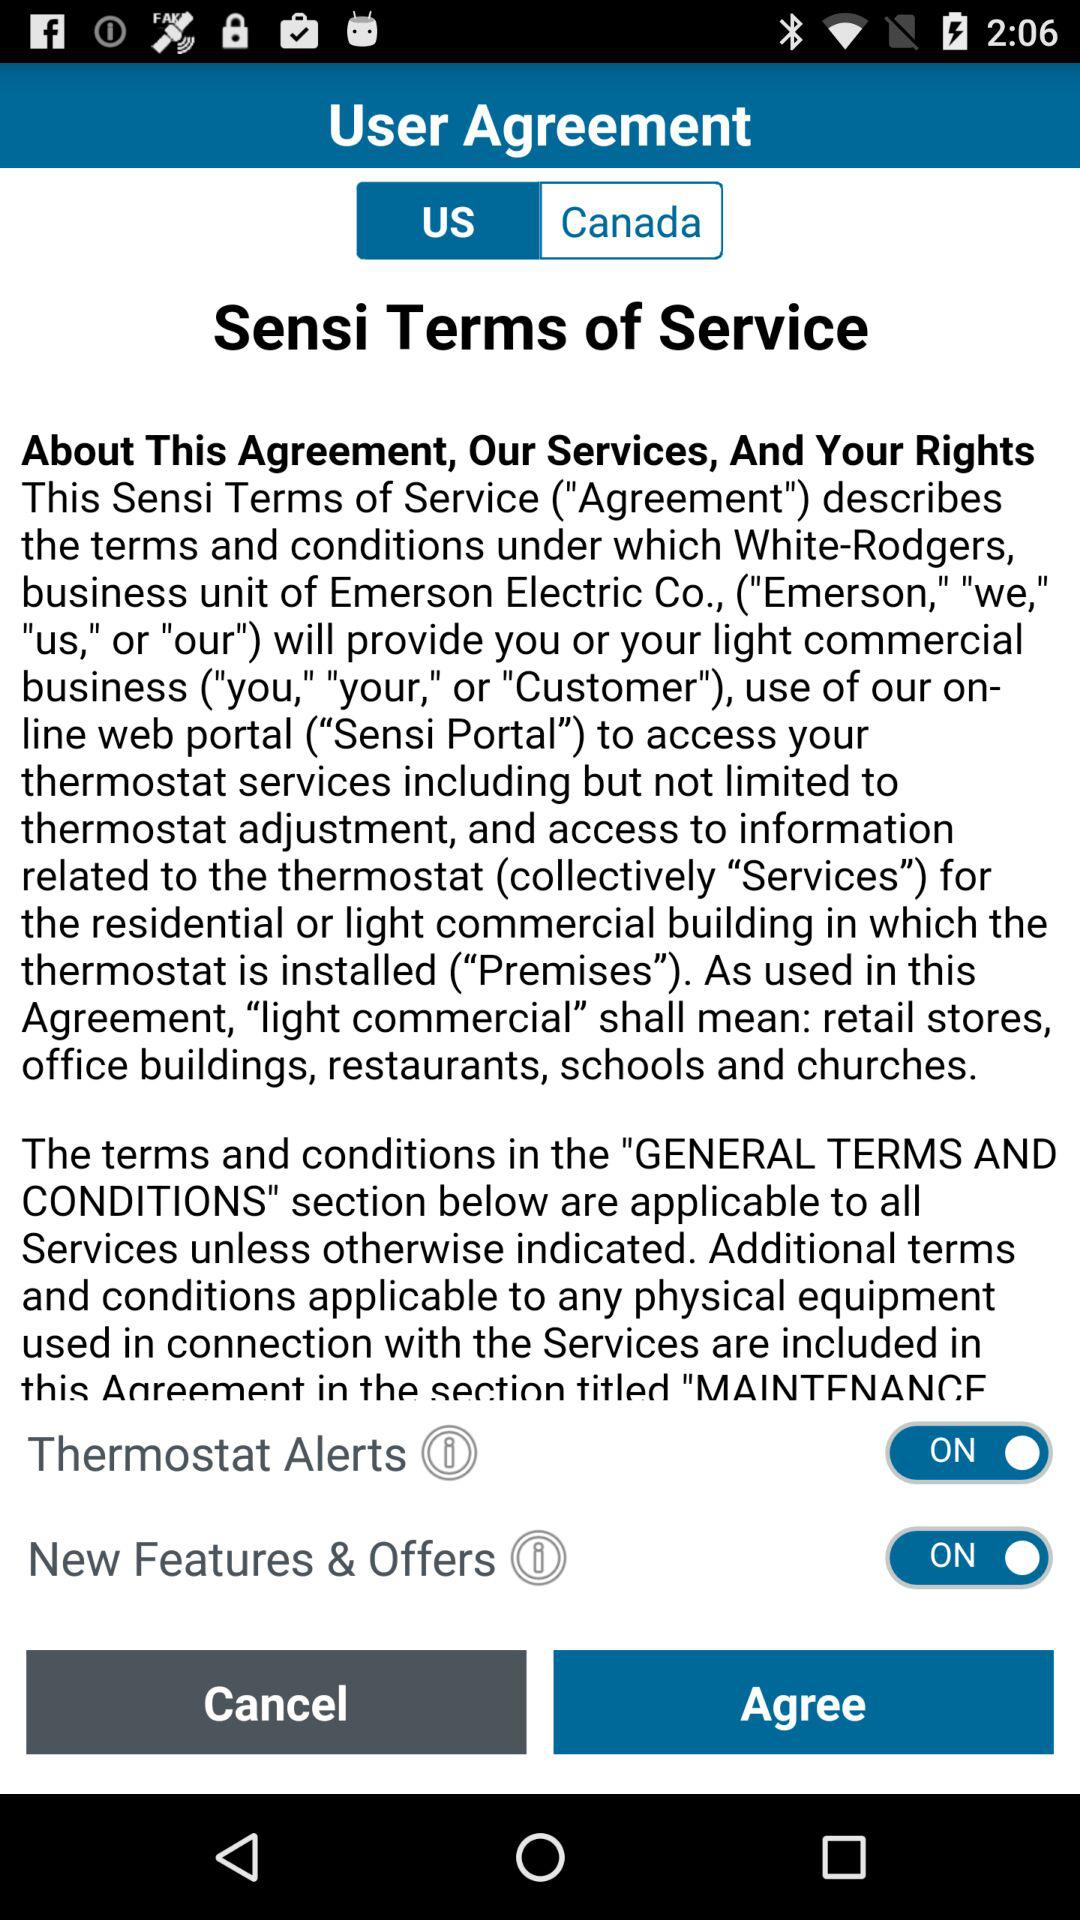Which user agreement is selected? The selected user agreement is for the US. 